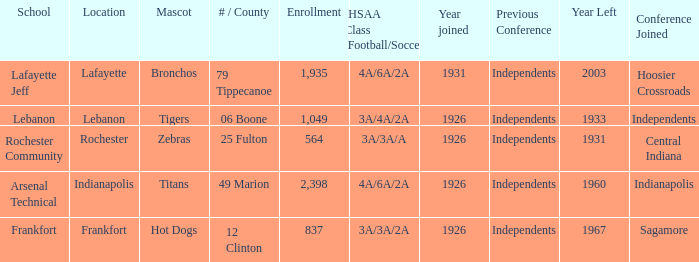What is the lowest enrollment that has Lafayette as the location? 1935.0. 